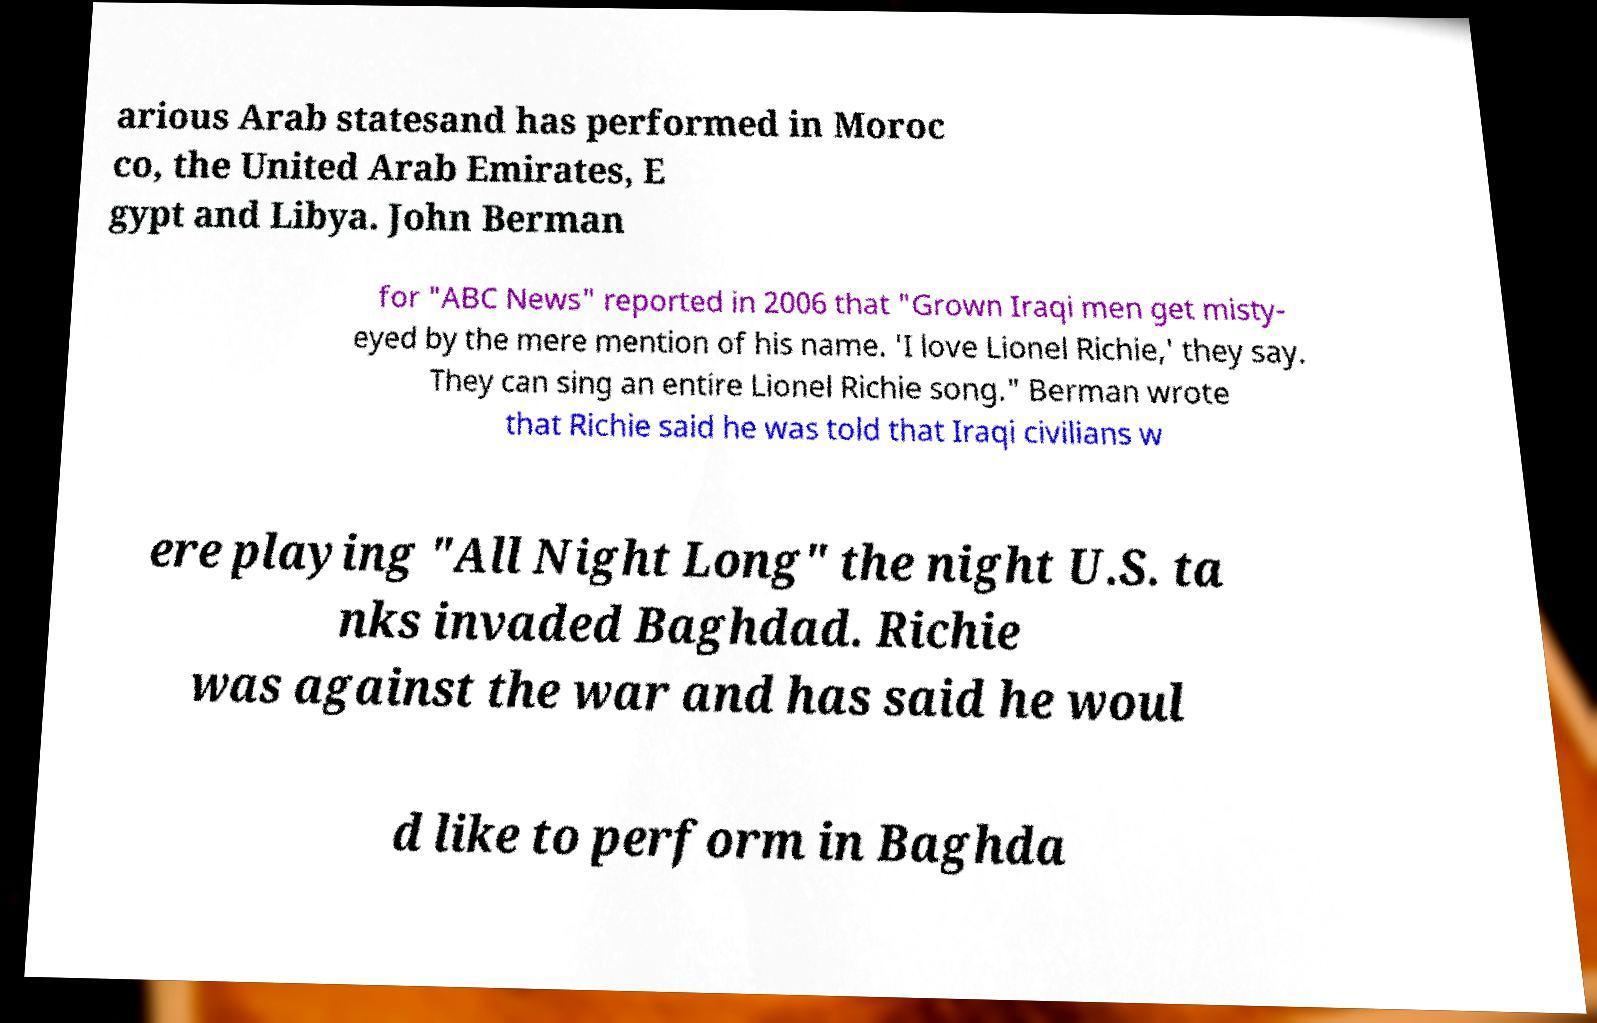Can you accurately transcribe the text from the provided image for me? arious Arab statesand has performed in Moroc co, the United Arab Emirates, E gypt and Libya. John Berman for "ABC News" reported in 2006 that "Grown Iraqi men get misty- eyed by the mere mention of his name. 'I love Lionel Richie,' they say. They can sing an entire Lionel Richie song." Berman wrote that Richie said he was told that Iraqi civilians w ere playing "All Night Long" the night U.S. ta nks invaded Baghdad. Richie was against the war and has said he woul d like to perform in Baghda 